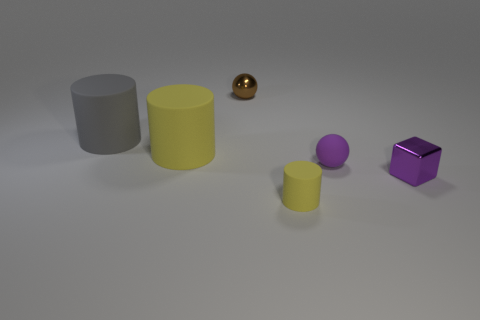What number of other objects are the same size as the cube?
Provide a short and direct response. 3. There is another big object that is the same shape as the gray rubber object; what is it made of?
Ensure brevity in your answer.  Rubber. What material is the yellow cylinder behind the yellow object right of the metallic thing that is behind the purple metallic thing?
Offer a terse response. Rubber. What size is the purple block that is made of the same material as the brown thing?
Your answer should be compact. Small. Is there any other thing that has the same color as the block?
Provide a short and direct response. Yes. Do the small metallic object behind the tiny block and the ball that is in front of the brown shiny ball have the same color?
Keep it short and to the point. No. There is a metallic object that is behind the block; what color is it?
Your response must be concise. Brown. Is the size of the yellow matte cylinder that is in front of the purple cube the same as the tiny purple cube?
Your response must be concise. Yes. Is the number of tiny purple objects less than the number of big gray matte cylinders?
Keep it short and to the point. No. The big matte object that is the same color as the small matte cylinder is what shape?
Your answer should be compact. Cylinder. 